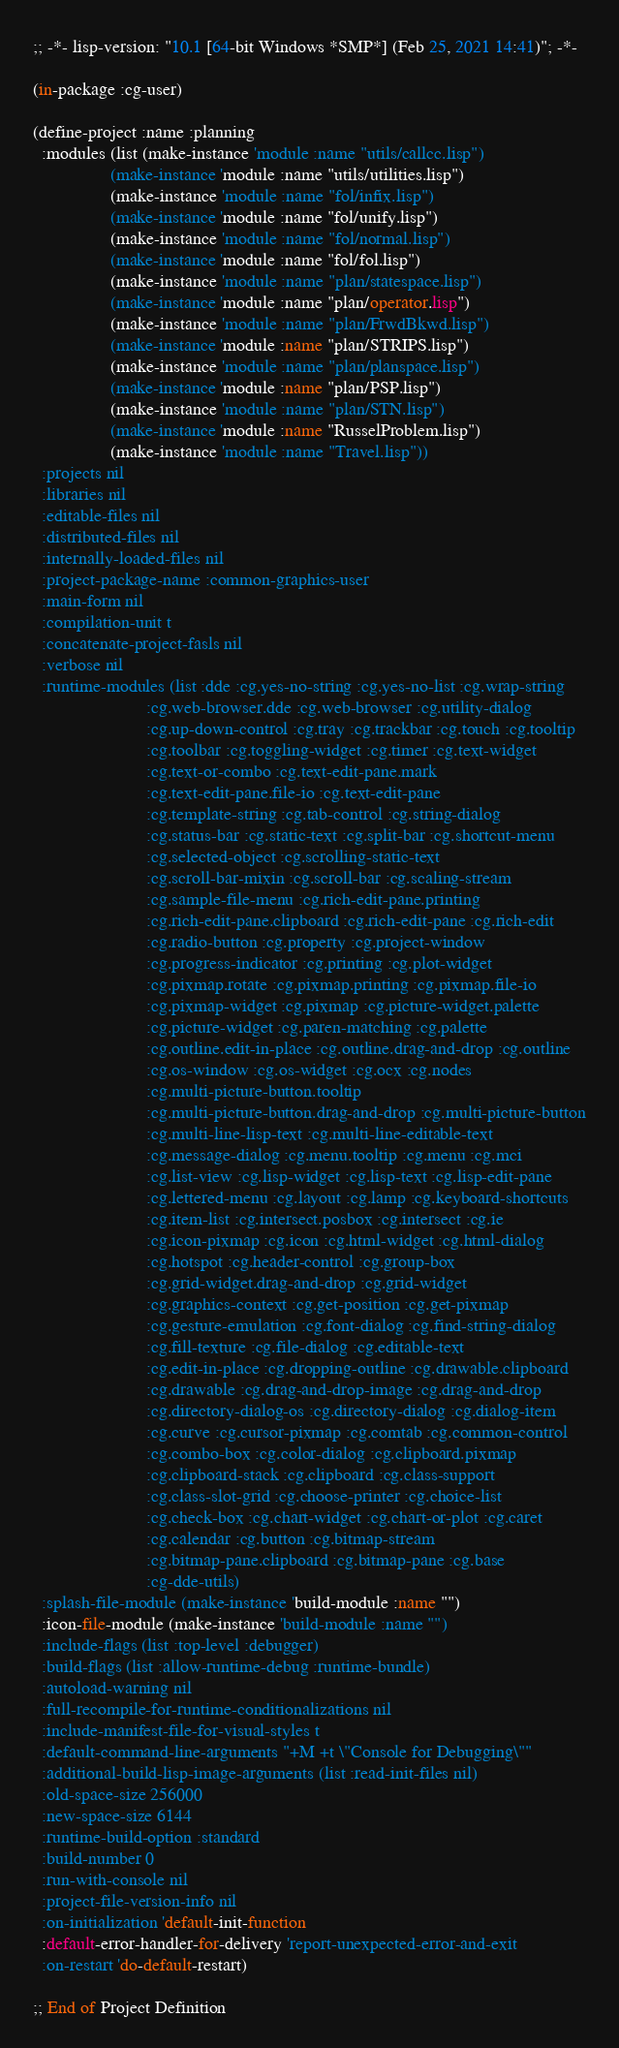<code> <loc_0><loc_0><loc_500><loc_500><_Pascal_>;; -*- lisp-version: "10.1 [64-bit Windows *SMP*] (Feb 25, 2021 14:41)"; -*-

(in-package :cg-user)

(define-project :name :planning
  :modules (list (make-instance 'module :name "utils/callcc.lisp")
                 (make-instance 'module :name "utils/utilities.lisp")
                 (make-instance 'module :name "fol/infix.lisp")
                 (make-instance 'module :name "fol/unify.lisp")
                 (make-instance 'module :name "fol/normal.lisp")
                 (make-instance 'module :name "fol/fol.lisp")
                 (make-instance 'module :name "plan/statespace.lisp")
                 (make-instance 'module :name "plan/operator.lisp")
                 (make-instance 'module :name "plan/FrwdBkwd.lisp")
                 (make-instance 'module :name "plan/STRIPS.lisp")
                 (make-instance 'module :name "plan/planspace.lisp")
                 (make-instance 'module :name "plan/PSP.lisp")
                 (make-instance 'module :name "plan/STN.lisp")
                 (make-instance 'module :name "RusselProblem.lisp")
                 (make-instance 'module :name "Travel.lisp"))
  :projects nil
  :libraries nil
  :editable-files nil
  :distributed-files nil
  :internally-loaded-files nil
  :project-package-name :common-graphics-user
  :main-form nil
  :compilation-unit t
  :concatenate-project-fasls nil
  :verbose nil
  :runtime-modules (list :dde :cg.yes-no-string :cg.yes-no-list :cg.wrap-string
                         :cg.web-browser.dde :cg.web-browser :cg.utility-dialog
                         :cg.up-down-control :cg.tray :cg.trackbar :cg.touch :cg.tooltip
                         :cg.toolbar :cg.toggling-widget :cg.timer :cg.text-widget
                         :cg.text-or-combo :cg.text-edit-pane.mark
                         :cg.text-edit-pane.file-io :cg.text-edit-pane
                         :cg.template-string :cg.tab-control :cg.string-dialog
                         :cg.status-bar :cg.static-text :cg.split-bar :cg.shortcut-menu
                         :cg.selected-object :cg.scrolling-static-text
                         :cg.scroll-bar-mixin :cg.scroll-bar :cg.scaling-stream
                         :cg.sample-file-menu :cg.rich-edit-pane.printing
                         :cg.rich-edit-pane.clipboard :cg.rich-edit-pane :cg.rich-edit
                         :cg.radio-button :cg.property :cg.project-window
                         :cg.progress-indicator :cg.printing :cg.plot-widget
                         :cg.pixmap.rotate :cg.pixmap.printing :cg.pixmap.file-io
                         :cg.pixmap-widget :cg.pixmap :cg.picture-widget.palette
                         :cg.picture-widget :cg.paren-matching :cg.palette
                         :cg.outline.edit-in-place :cg.outline.drag-and-drop :cg.outline
                         :cg.os-window :cg.os-widget :cg.ocx :cg.nodes
                         :cg.multi-picture-button.tooltip
                         :cg.multi-picture-button.drag-and-drop :cg.multi-picture-button
                         :cg.multi-line-lisp-text :cg.multi-line-editable-text
                         :cg.message-dialog :cg.menu.tooltip :cg.menu :cg.mci
                         :cg.list-view :cg.lisp-widget :cg.lisp-text :cg.lisp-edit-pane
                         :cg.lettered-menu :cg.layout :cg.lamp :cg.keyboard-shortcuts
                         :cg.item-list :cg.intersect.posbox :cg.intersect :cg.ie
                         :cg.icon-pixmap :cg.icon :cg.html-widget :cg.html-dialog
                         :cg.hotspot :cg.header-control :cg.group-box
                         :cg.grid-widget.drag-and-drop :cg.grid-widget
                         :cg.graphics-context :cg.get-position :cg.get-pixmap
                         :cg.gesture-emulation :cg.font-dialog :cg.find-string-dialog
                         :cg.fill-texture :cg.file-dialog :cg.editable-text
                         :cg.edit-in-place :cg.dropping-outline :cg.drawable.clipboard
                         :cg.drawable :cg.drag-and-drop-image :cg.drag-and-drop
                         :cg.directory-dialog-os :cg.directory-dialog :cg.dialog-item
                         :cg.curve :cg.cursor-pixmap :cg.comtab :cg.common-control
                         :cg.combo-box :cg.color-dialog :cg.clipboard.pixmap
                         :cg.clipboard-stack :cg.clipboard :cg.class-support
                         :cg.class-slot-grid :cg.choose-printer :cg.choice-list
                         :cg.check-box :cg.chart-widget :cg.chart-or-plot :cg.caret
                         :cg.calendar :cg.button :cg.bitmap-stream
                         :cg.bitmap-pane.clipboard :cg.bitmap-pane :cg.base
                         :cg-dde-utils)
  :splash-file-module (make-instance 'build-module :name "")
  :icon-file-module (make-instance 'build-module :name "")
  :include-flags (list :top-level :debugger)
  :build-flags (list :allow-runtime-debug :runtime-bundle)
  :autoload-warning nil
  :full-recompile-for-runtime-conditionalizations nil
  :include-manifest-file-for-visual-styles t
  :default-command-line-arguments "+M +t \"Console for Debugging\""
  :additional-build-lisp-image-arguments (list :read-init-files nil)
  :old-space-size 256000
  :new-space-size 6144
  :runtime-build-option :standard
  :build-number 0
  :run-with-console nil
  :project-file-version-info nil
  :on-initialization 'default-init-function
  :default-error-handler-for-delivery 'report-unexpected-error-and-exit
  :on-restart 'do-default-restart)

;; End of Project Definition
</code> 